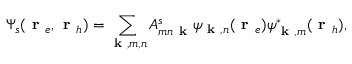Convert formula to latex. <formula><loc_0><loc_0><loc_500><loc_500>\Psi _ { s } ( r _ { e } , r _ { h } ) = \sum _ { k , m , n } A _ { m n k } ^ { s } \psi _ { k , n } ( r _ { e } ) \psi _ { k , m } ^ { * } ( r _ { h } ) ,</formula> 